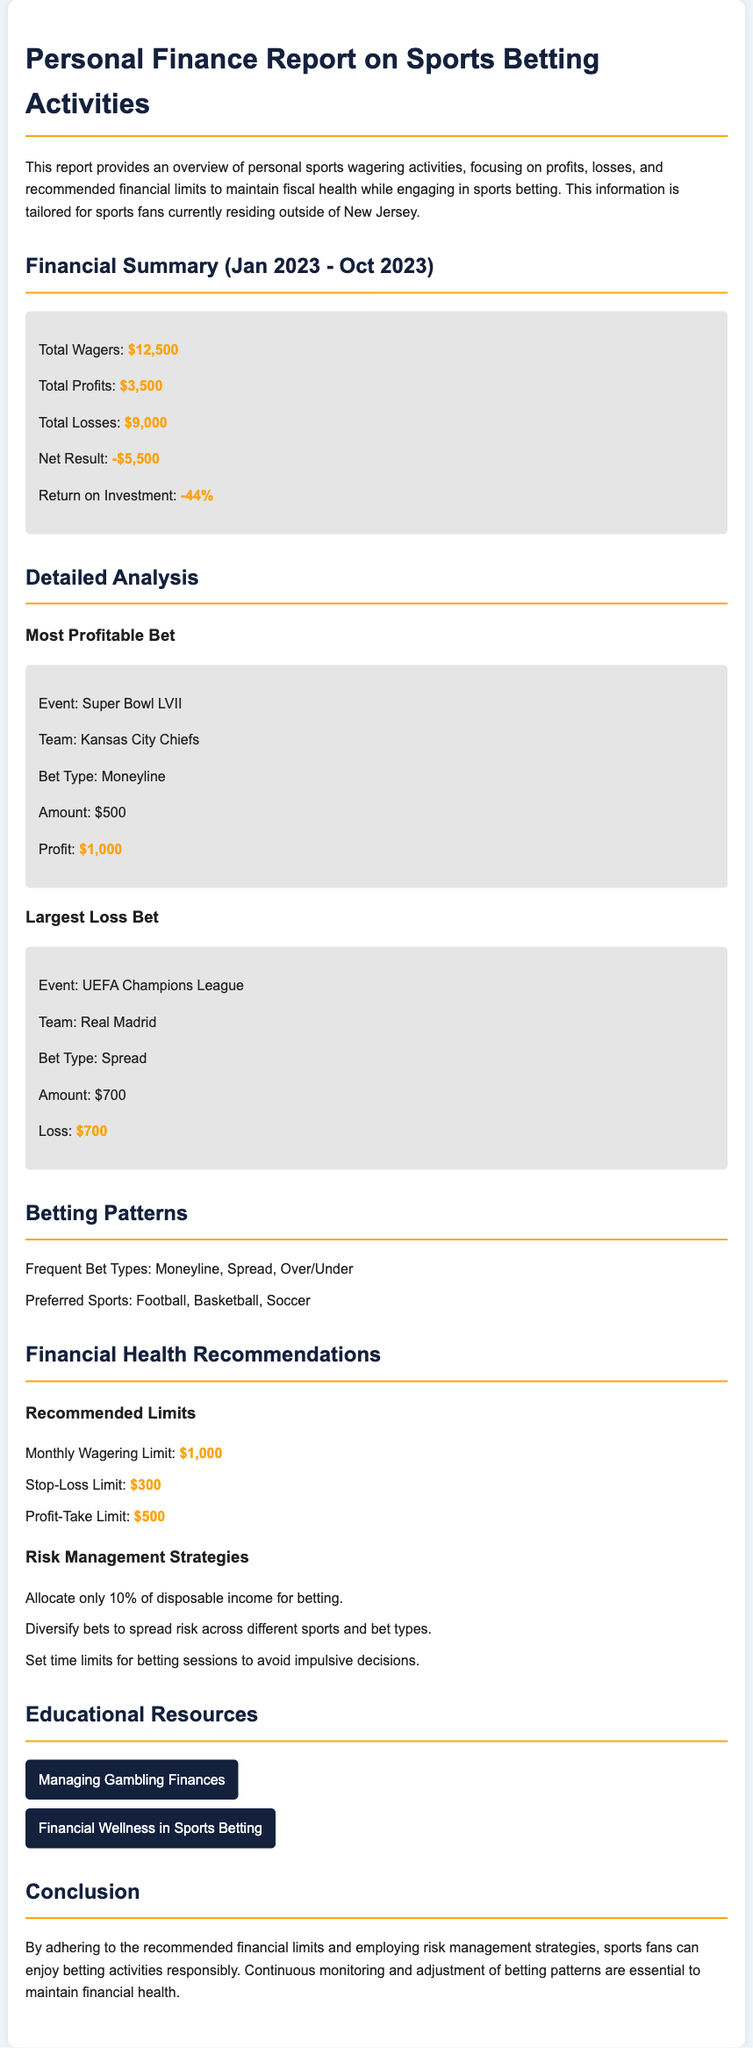What is the total amount wagered? The document states that the total wagers made were $12,500.
Answer: $12,500 What is the net result of the betting activities? The net result is calculated by subtracting total losses from total profits, resulting in -$5,500.
Answer: -$5,500 What was the profit from the most profitable bet? The document indicates that the profit from the most profitable bet on the Super Bowl LVII was $1,000.
Answer: $1,000 What is the recommended monthly wagering limit? The recommended monthly wagering limit stated in the document is $1,000.
Answer: $1,000 Which team won the most profitable bet? The team that won in the most profitable bet was the Kansas City Chiefs.
Answer: Kansas City Chiefs What is the return on investment percentage? The return on investment percentage is calculated as -44%, as noted in the financial summary.
Answer: -44% What is the stop-loss limit? The stop-loss limit recommended in the report is $300.
Answer: $300 What bet type was used for the largest loss? The bet type for the largest loss was a Spread bet.
Answer: Spread How can one diversify bets according to the recommendations? The document suggests diversifying bets across different sports and bet types.
Answer: Different sports and bet types 